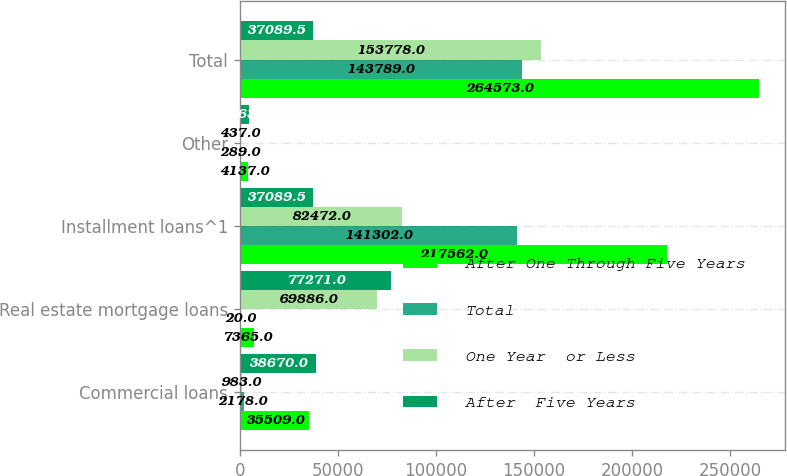Convert chart to OTSL. <chart><loc_0><loc_0><loc_500><loc_500><stacked_bar_chart><ecel><fcel>Commercial loans<fcel>Real estate mortgage loans<fcel>Installment loans^1<fcel>Other<fcel>Total<nl><fcel>After One Through Five Years<fcel>35509<fcel>7365<fcel>217562<fcel>4137<fcel>264573<nl><fcel>Total<fcel>2178<fcel>20<fcel>141302<fcel>289<fcel>143789<nl><fcel>One Year  or Less<fcel>983<fcel>69886<fcel>82472<fcel>437<fcel>153778<nl><fcel>After  Five Years<fcel>38670<fcel>77271<fcel>37089.5<fcel>4863<fcel>37089.5<nl></chart> 